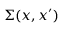<formula> <loc_0><loc_0><loc_500><loc_500>\Sigma ( x , x ^ { \prime } )</formula> 